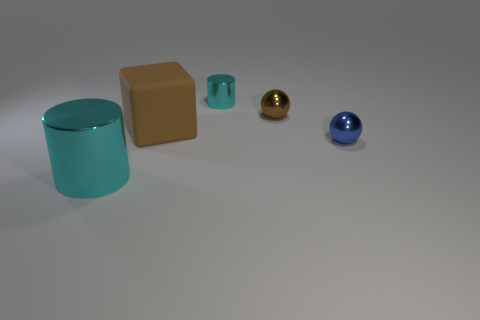Add 4 rubber objects. How many objects exist? 9 Subtract all blue balls. How many balls are left? 1 Subtract 0 blue cubes. How many objects are left? 5 Subtract all cubes. How many objects are left? 4 Subtract 2 cylinders. How many cylinders are left? 0 Subtract all blue balls. Subtract all brown cylinders. How many balls are left? 1 Subtract all brown cubes. How many cyan balls are left? 0 Subtract all brown cubes. Subtract all green matte balls. How many objects are left? 4 Add 1 blue spheres. How many blue spheres are left? 2 Add 1 blue balls. How many blue balls exist? 2 